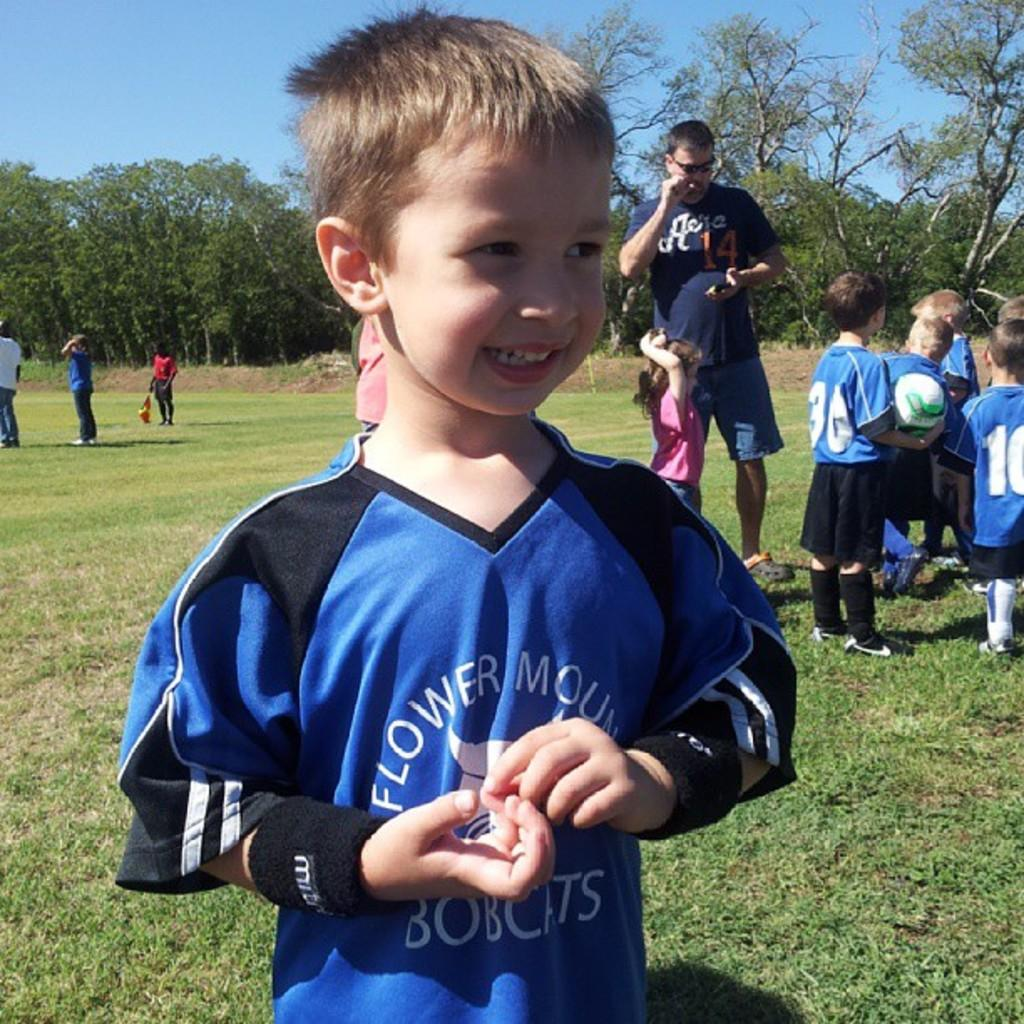Provide a one-sentence caption for the provided image. A small boy waits to play football in the park wearing a Flower Mount Bobcats jersey. 